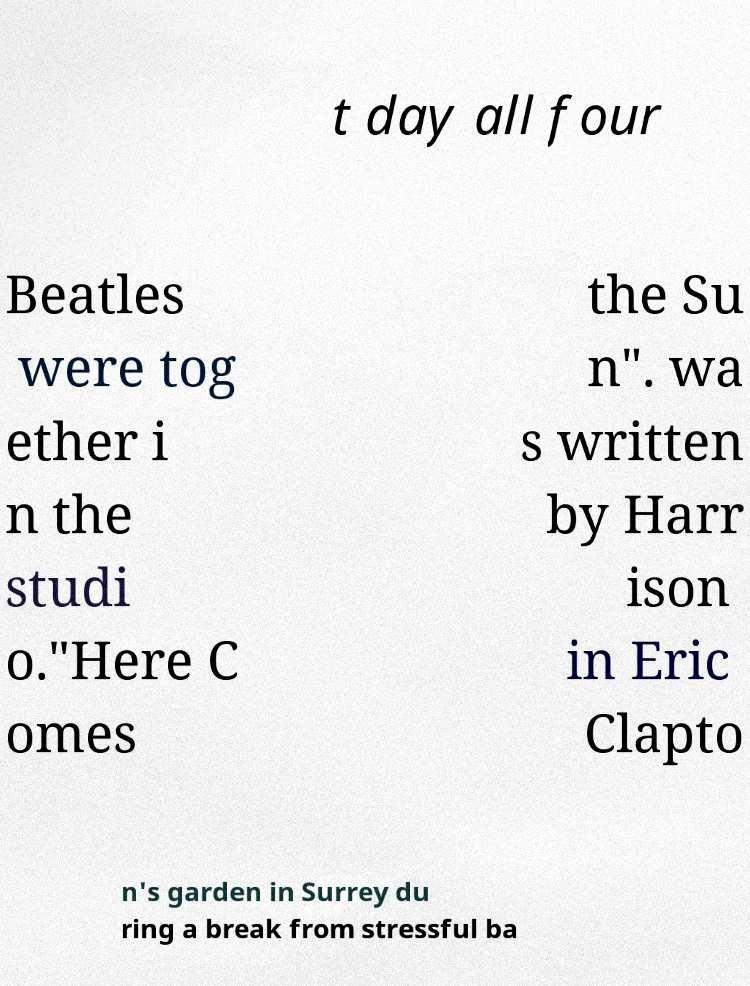There's text embedded in this image that I need extracted. Can you transcribe it verbatim? t day all four Beatles were tog ether i n the studi o."Here C omes the Su n". wa s written by Harr ison in Eric Clapto n's garden in Surrey du ring a break from stressful ba 